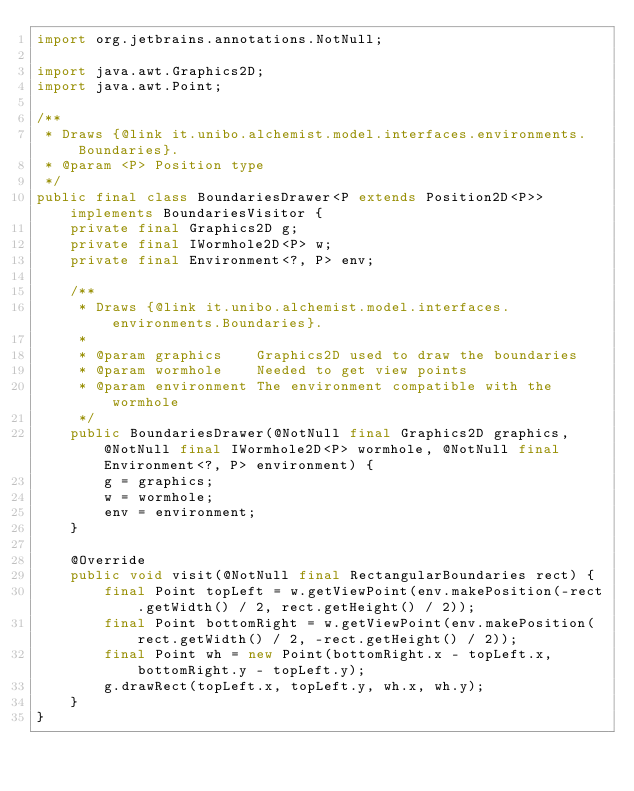Convert code to text. <code><loc_0><loc_0><loc_500><loc_500><_Java_>import org.jetbrains.annotations.NotNull;

import java.awt.Graphics2D;
import java.awt.Point;

/**
 * Draws {@link it.unibo.alchemist.model.interfaces.environments.Boundaries}.
 * @param <P> Position type
 */
public final class BoundariesDrawer<P extends Position2D<P>> implements BoundariesVisitor {
    private final Graphics2D g;
    private final IWormhole2D<P> w;
    private final Environment<?, P> env;

    /**
     * Draws {@link it.unibo.alchemist.model.interfaces.environments.Boundaries}.
     *
     * @param graphics    Graphics2D used to draw the boundaries
     * @param wormhole    Needed to get view points
     * @param environment The environment compatible with the wormhole
     */
    public BoundariesDrawer(@NotNull final Graphics2D graphics, @NotNull final IWormhole2D<P> wormhole, @NotNull final Environment<?, P> environment) {
        g = graphics;
        w = wormhole;
        env = environment;
    }

    @Override
    public void visit(@NotNull final RectangularBoundaries rect) {
        final Point topLeft = w.getViewPoint(env.makePosition(-rect.getWidth() / 2, rect.getHeight() / 2));
        final Point bottomRight = w.getViewPoint(env.makePosition(rect.getWidth() / 2, -rect.getHeight() / 2));
        final Point wh = new Point(bottomRight.x - topLeft.x, bottomRight.y - topLeft.y);
        g.drawRect(topLeft.x, topLeft.y, wh.x, wh.y);
    }
}
</code> 